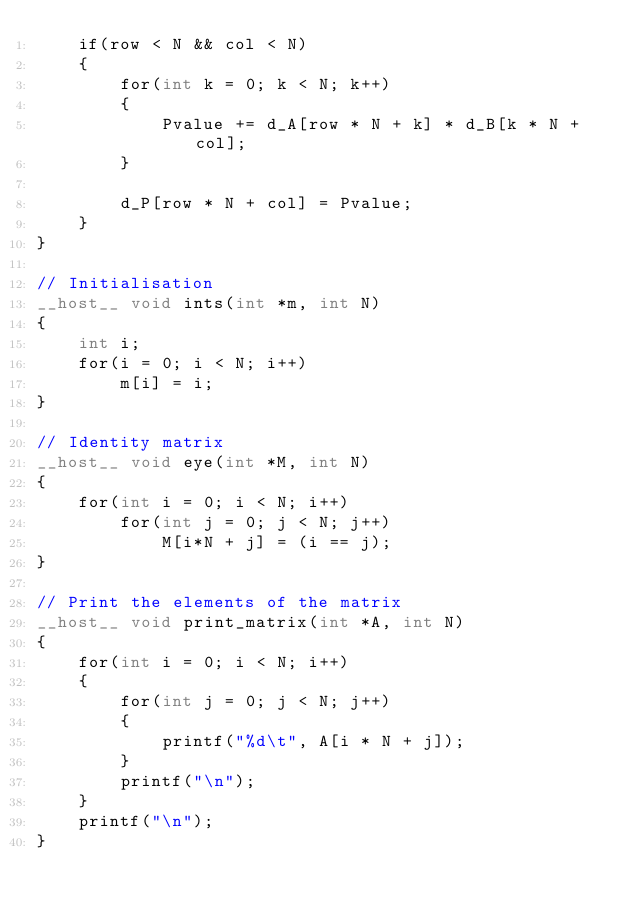<code> <loc_0><loc_0><loc_500><loc_500><_Cuda_>    if(row < N && col < N)
    {
        for(int k = 0; k < N; k++)
        {
            Pvalue += d_A[row * N + k] * d_B[k * N + col];
        }

        d_P[row * N + col] = Pvalue;
    }
}

// Initialisation
__host__ void ints(int *m, int N)
{
    int i;
    for(i = 0; i < N; i++)
        m[i] = i;
}

// Identity matrix
__host__ void eye(int *M, int N)
{
    for(int i = 0; i < N; i++)
        for(int j = 0; j < N; j++)
            M[i*N + j] = (i == j);
}

// Print the elements of the matrix
__host__ void print_matrix(int *A, int N)
{
    for(int i = 0; i < N; i++)
    {
        for(int j = 0; j < N; j++)
        {
            printf("%d\t", A[i * N + j]);
        }
        printf("\n");
    }
    printf("\n");
}
</code> 